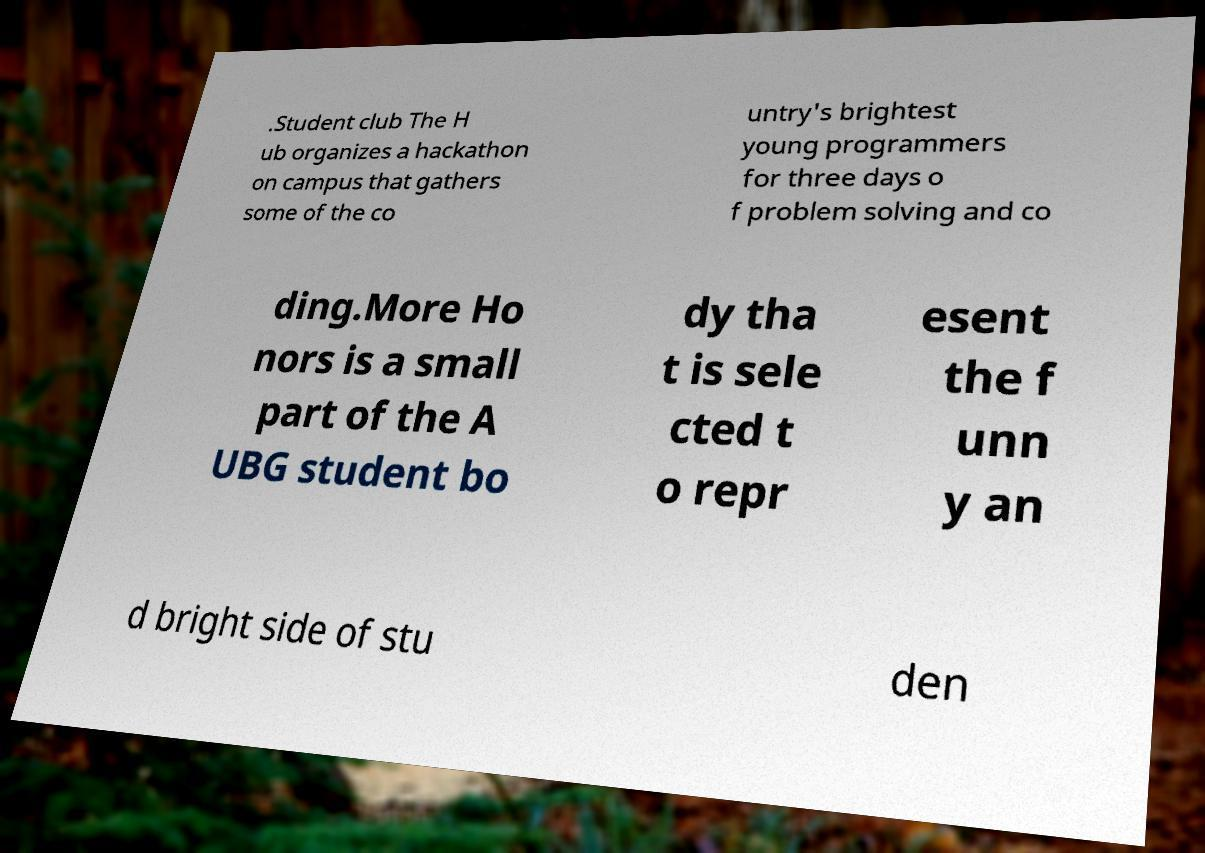There's text embedded in this image that I need extracted. Can you transcribe it verbatim? .Student club The H ub organizes a hackathon on campus that gathers some of the co untry's brightest young programmers for three days o f problem solving and co ding.More Ho nors is a small part of the A UBG student bo dy tha t is sele cted t o repr esent the f unn y an d bright side of stu den 